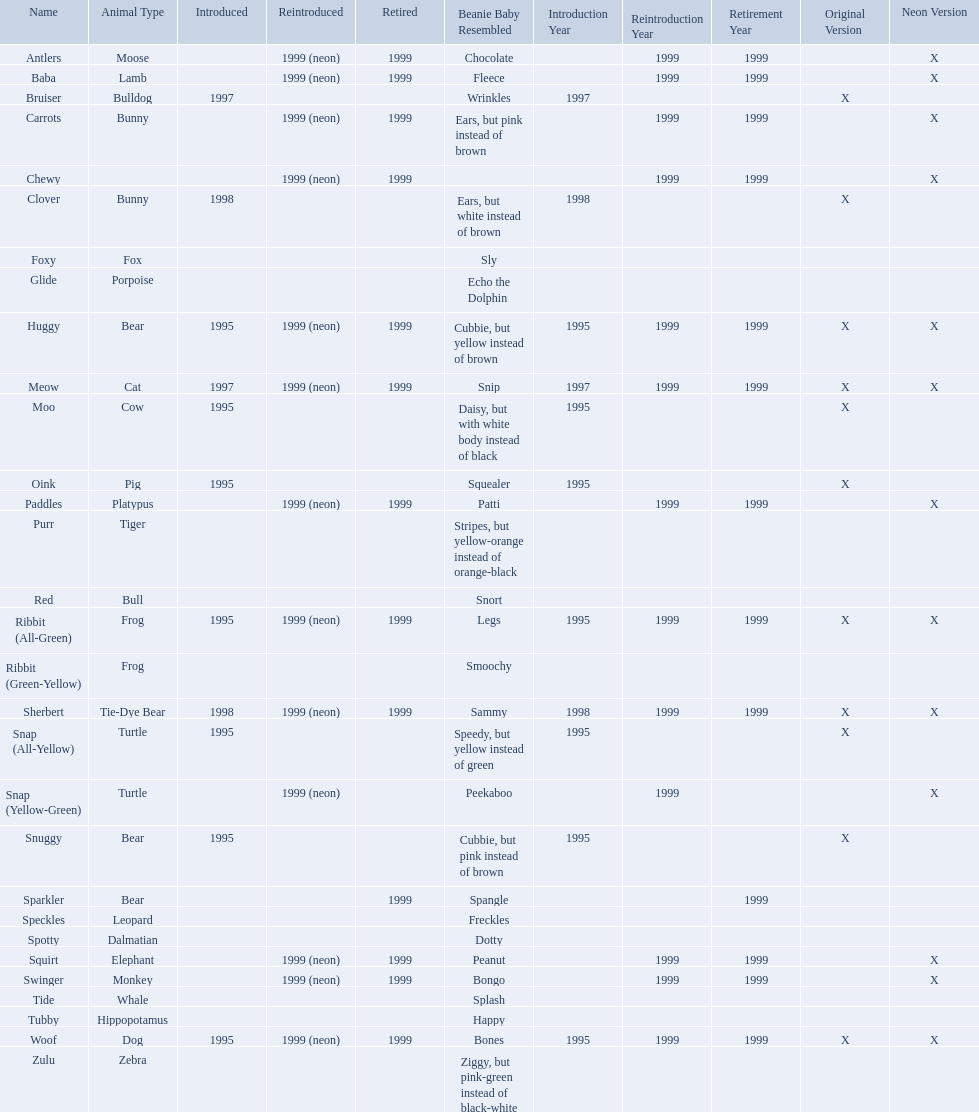Which of the listed pillow pals lack information in at least 3 categories? Chewy, Foxy, Glide, Purr, Red, Ribbit (Green-Yellow), Speckles, Spotty, Tide, Tubby, Zulu. Of those, which one lacks information in the animal type category? Chewy. What are the names listed? Antlers, Baba, Bruiser, Carrots, Chewy, Clover, Foxy, Glide, Huggy, Meow, Moo, Oink, Paddles, Purr, Red, Ribbit (All-Green), Ribbit (Green-Yellow), Sherbert, Snap (All-Yellow), Snap (Yellow-Green), Snuggy, Sparkler, Speckles, Spotty, Squirt, Swinger, Tide, Tubby, Woof, Zulu. Of these, which is the only pet without an animal type listed? Chewy. What are all the pillow pals? Antlers, Baba, Bruiser, Carrots, Chewy, Clover, Foxy, Glide, Huggy, Meow, Moo, Oink, Paddles, Purr, Red, Ribbit (All-Green), Ribbit (Green-Yellow), Sherbert, Snap (All-Yellow), Snap (Yellow-Green), Snuggy, Sparkler, Speckles, Spotty, Squirt, Swinger, Tide, Tubby, Woof, Zulu. Which is the only without a listed animal type? Chewy. 